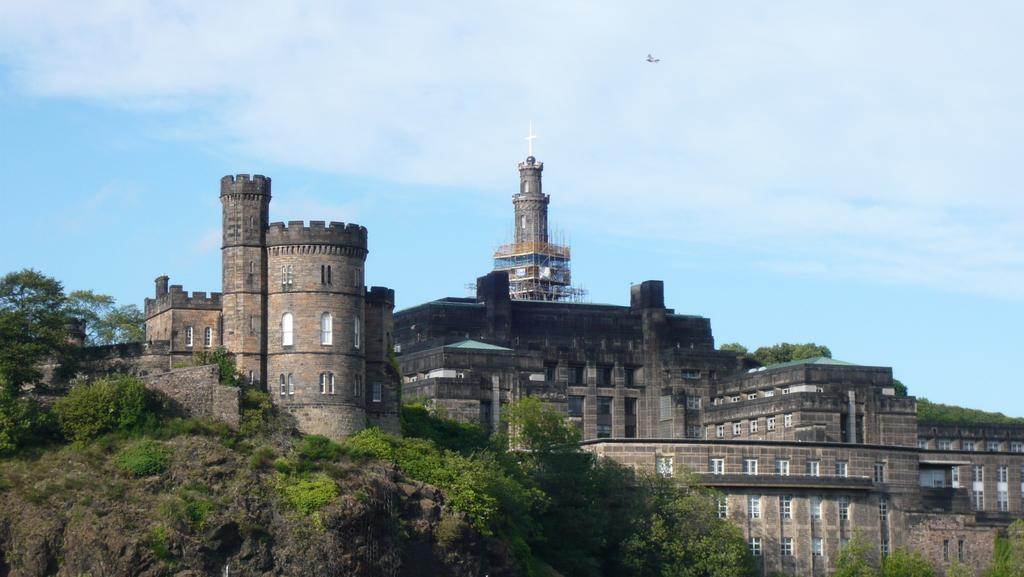What type of vegetation is on the left side of the image? There are trees on the left side of the image. What is the main structure in the middle of the image? There is a very big building in the middle of the image. What is visible at the top of the image? The sky is visible at the top of the image. What type of theory is being discussed in the cave in the image? There is no cave present in the image, and therefore no theory can be discussed. What type of business is being conducted in the building in the image? The image does not provide any information about the purpose or activity of the building, so it is not possible to determine what type of business might be conducted there. 